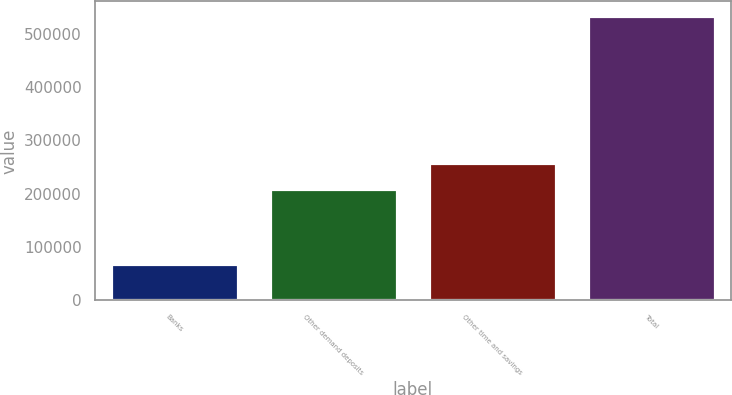Convert chart. <chart><loc_0><loc_0><loc_500><loc_500><bar_chart><fcel>Banks<fcel>Other demand deposits<fcel>Other time and savings<fcel>Total<nl><fcel>68538<fcel>208634<fcel>256946<fcel>534118<nl></chart> 